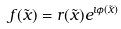<formula> <loc_0><loc_0><loc_500><loc_500>f ( \tilde { x } ) = r ( \tilde { x } ) e ^ { \imath \phi ( \tilde { x } ) }</formula> 